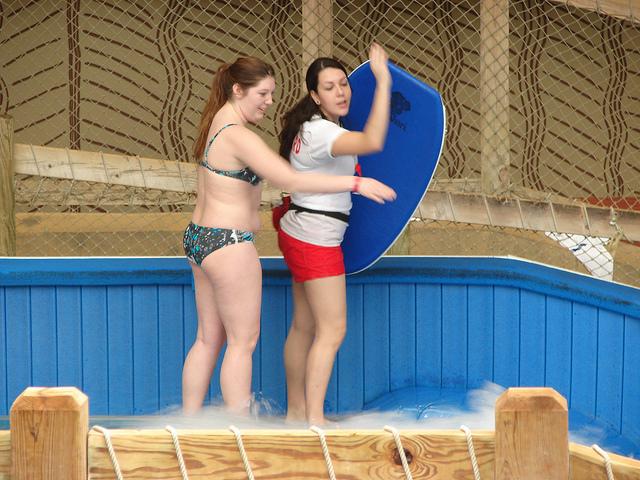Does this look like it would be fun?
Quick response, please. Yes. What is the girl holding?
Be succinct. Boogie board. What are the woman getting ready to do?
Be succinct. Water slide. 